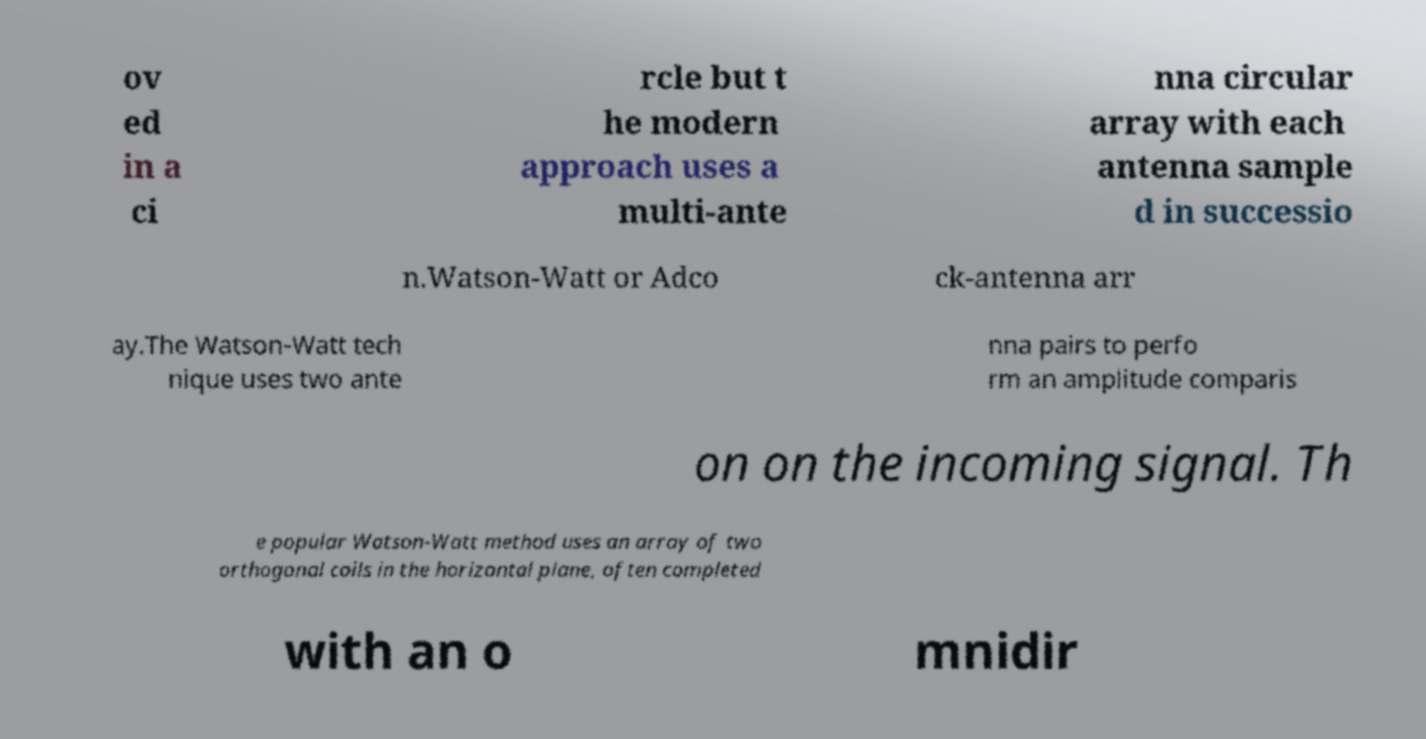For documentation purposes, I need the text within this image transcribed. Could you provide that? ov ed in a ci rcle but t he modern approach uses a multi-ante nna circular array with each antenna sample d in successio n.Watson-Watt or Adco ck-antenna arr ay.The Watson-Watt tech nique uses two ante nna pairs to perfo rm an amplitude comparis on on the incoming signal. Th e popular Watson-Watt method uses an array of two orthogonal coils in the horizontal plane, often completed with an o mnidir 